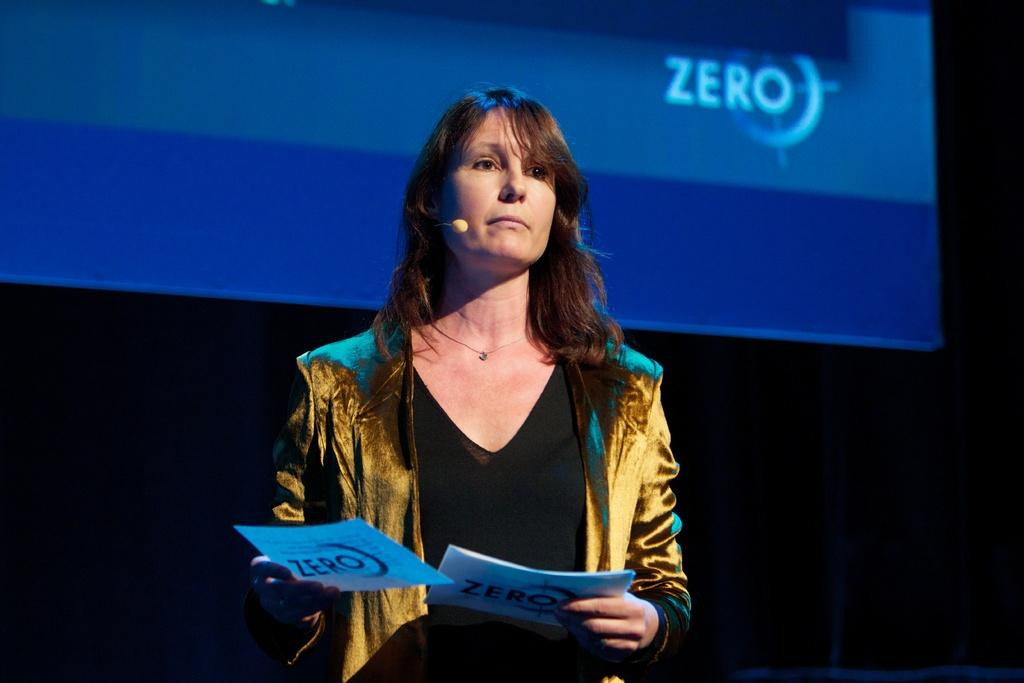Who is present in the image? There is a woman in the image. What is the woman holding? The woman is holding papers. What can be seen in the background of the image? There is a big screen in the background of the image. What is the purpose of the debt in the image? There is no mention of debt in the image; it is not present. 